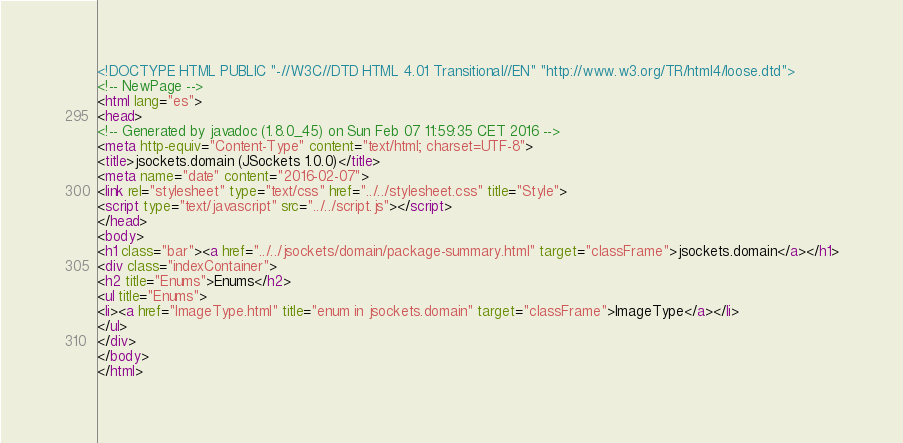<code> <loc_0><loc_0><loc_500><loc_500><_HTML_><!DOCTYPE HTML PUBLIC "-//W3C//DTD HTML 4.01 Transitional//EN" "http://www.w3.org/TR/html4/loose.dtd">
<!-- NewPage -->
<html lang="es">
<head>
<!-- Generated by javadoc (1.8.0_45) on Sun Feb 07 11:59:35 CET 2016 -->
<meta http-equiv="Content-Type" content="text/html; charset=UTF-8">
<title>jsockets.domain (JSockets 1.0.0)</title>
<meta name="date" content="2016-02-07">
<link rel="stylesheet" type="text/css" href="../../stylesheet.css" title="Style">
<script type="text/javascript" src="../../script.js"></script>
</head>
<body>
<h1 class="bar"><a href="../../jsockets/domain/package-summary.html" target="classFrame">jsockets.domain</a></h1>
<div class="indexContainer">
<h2 title="Enums">Enums</h2>
<ul title="Enums">
<li><a href="ImageType.html" title="enum in jsockets.domain" target="classFrame">ImageType</a></li>
</ul>
</div>
</body>
</html>
</code> 